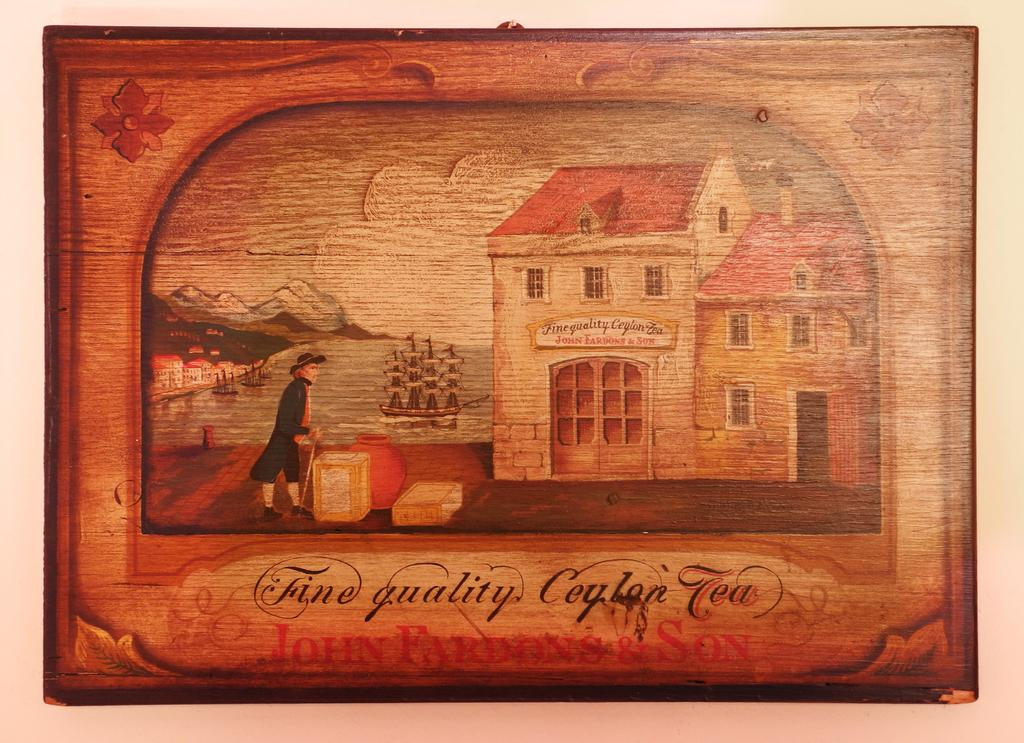<image>
Summarize the visual content of the image. a man in a long coat standing in front of a wooden building and tea wrote below it 